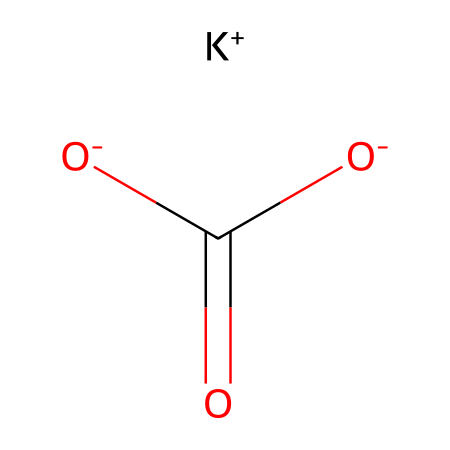What is the name of this chemical? The chemical represented by the given SMILES notation is potassium bicarbonate. The potassium ion (K+) and the bicarbonate ion [O-]C(=O)[O-] indicate the presence of potassium and bicarbonate groups, respectively, which are conventionally recognized in chemical nomenclature.
Answer: potassium bicarbonate How many oxygen atoms are present in the bicarbonate part? In the structure, the bicarbonate ion shows that there are three oxygen atoms bonded to the carbon and connected via two single bonds and one double bond. Thus, adding these together provides the total count of oxygen atoms.
Answer: three What charge does the potassium ion carry? The potassium ion is represented as K+, which indicates a positive charge on the potassium atom. The "+" sign clearly denotes that it has lost one electron compared to its neutral state.
Answer: positive How many total bonds are present in the molecular structure? Analyzing the SMILES, the molecular arrangement includes one double bond (C=O) and two single bonds within the bicarbonate ion, plus the ionic bond between the potassium ion and the bicarbonate ion. Adding these reveals the total number of bonds present in the molecule.
Answer: three What category of electrolyte does potassium bicarbonate belong to? Potassium bicarbonate is classified as an ionic electrolyte, as it dissociates into potassium and bicarbonate ions in solution, which is typical behavior for electrolytes affected by their ionic nature.
Answer: ionic Why is potassium bicarbonate commonly used in effervescent tablets? In effervescent tablets, potassium bicarbonate reacts with acids (like citric acid) to produce carbon dioxide gas, leading to effervescence. This reaction not only serves a functional purpose but also provides a visually appealing characteristic when the tablet dissolves in water.
Answer: effervescence 